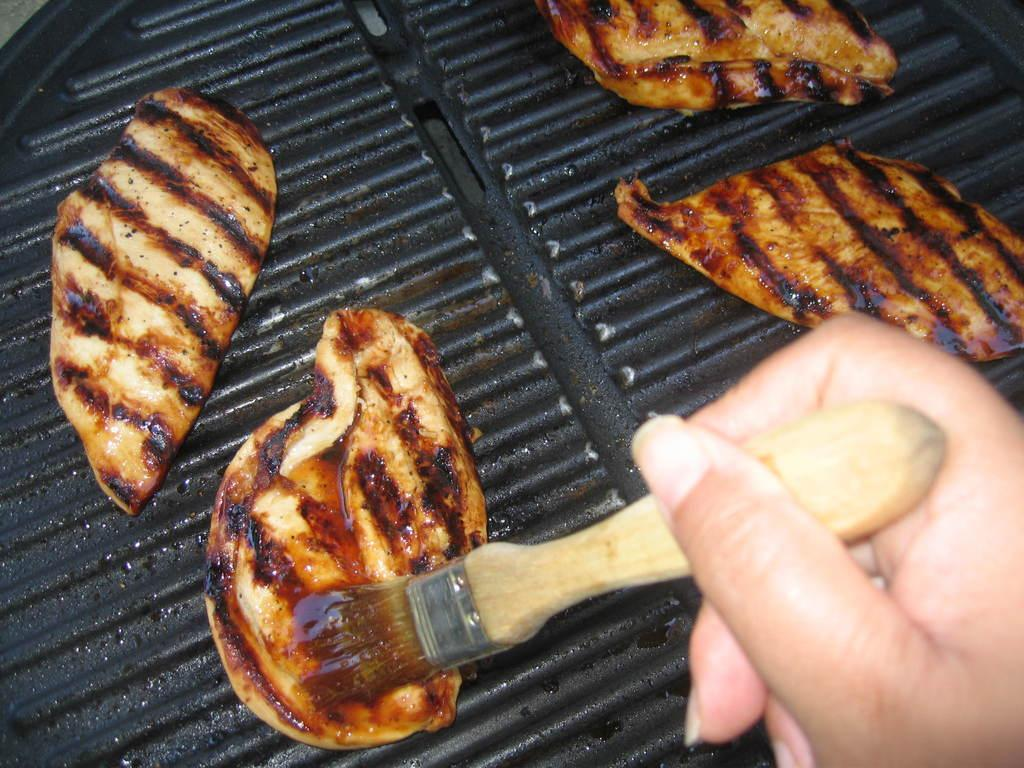What is the color of the grill in the image? The grill in the image is black. What is being cooked on the grill? There are food items on the grill. Can you describe the person's hand in the image? A person's hand is holding a brush in the image. What type of stocking is being used to cook the food on the grill? There is no mention of stockings in the image. --- Facts: 1. There is a person in the image. 2. The person is wearing a hat. 3. The person is holding a book. Absurd Topics: parrot, dance, ocean Conversation: Who or what is in the image? There is a person in the image. What is the person wearing? The person is wearing a hat. What is the person holding? The person is holding a book. Reasoning: Let's think step by step in order to produce the conversation. We start by identifying the main subject of the image, which is the person. Next, we describe specific features of the person, such as the hat. Then, we observe the actions of the person, noting that they are holding a book. Finally, we avoid any yes/no questions and ensure that the language is simple and clear. Absurd Question/Answer: Can you see a parrot dancing in the ocean in the image? There is no mention of a parrot, dancing, or the ocean in the image. 